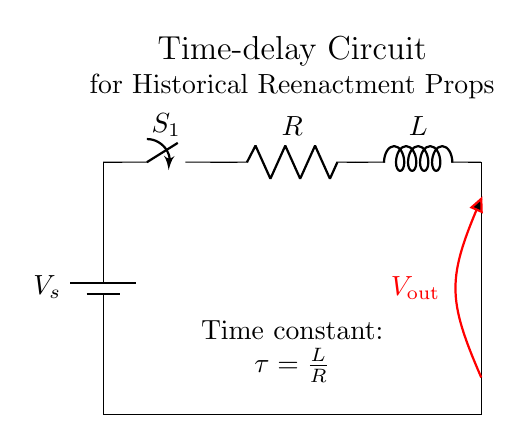What components are in the circuit? The circuit consists of a battery, a switch, a resistor, and an inductor. These components are clearly labeled in the diagram.
Answer: battery, switch, resistor, inductor What is the purpose of the switch in this circuit? The switch is used to control the flow of current through the circuit. When closed, it allows current to pass, activating the circuit.
Answer: control current What is the time constant of the circuit? The time constant is denoted by the formula τ = L/R, which indicates the relationship between the inductance and resistance. This information is provided in the circuit diagram.
Answer: τ = L/R How does the inductor affect the circuit when the switch is closed? The inductor opposes changes in current flow, leading to a delay in the rise of current and influencing the time delay of the circuit's output voltage.
Answer: delays current rise What is the output voltage represented as in the diagram? The output voltage is represented as Vout, showing the voltage measured across the inductor and related to the time delay of the circuit.
Answer: Vout What happens to the time constant if the resistance is increased? Increasing the resistance will decrease the time constant τ, which means the delay in current and voltage will be shorter. This shows an inverse relationship between resistance and the time constant.
Answer: decreases 